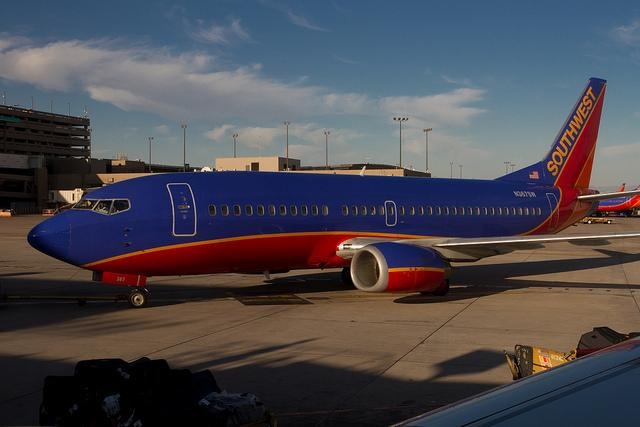What is the blue plane used for? Please explain your reasoning. commercial travel. It has the name of the company on the tail 